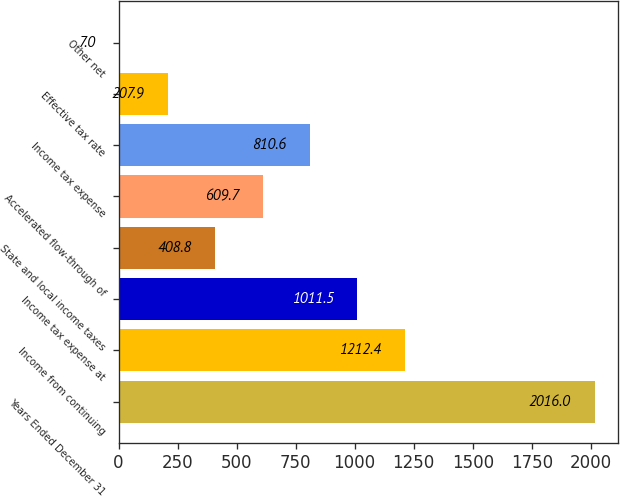Convert chart to OTSL. <chart><loc_0><loc_0><loc_500><loc_500><bar_chart><fcel>Years Ended December 31<fcel>Income from continuing<fcel>Income tax expense at<fcel>State and local income taxes<fcel>Accelerated flow-through of<fcel>Income tax expense<fcel>Effective tax rate<fcel>Other net<nl><fcel>2016<fcel>1212.4<fcel>1011.5<fcel>408.8<fcel>609.7<fcel>810.6<fcel>207.9<fcel>7<nl></chart> 